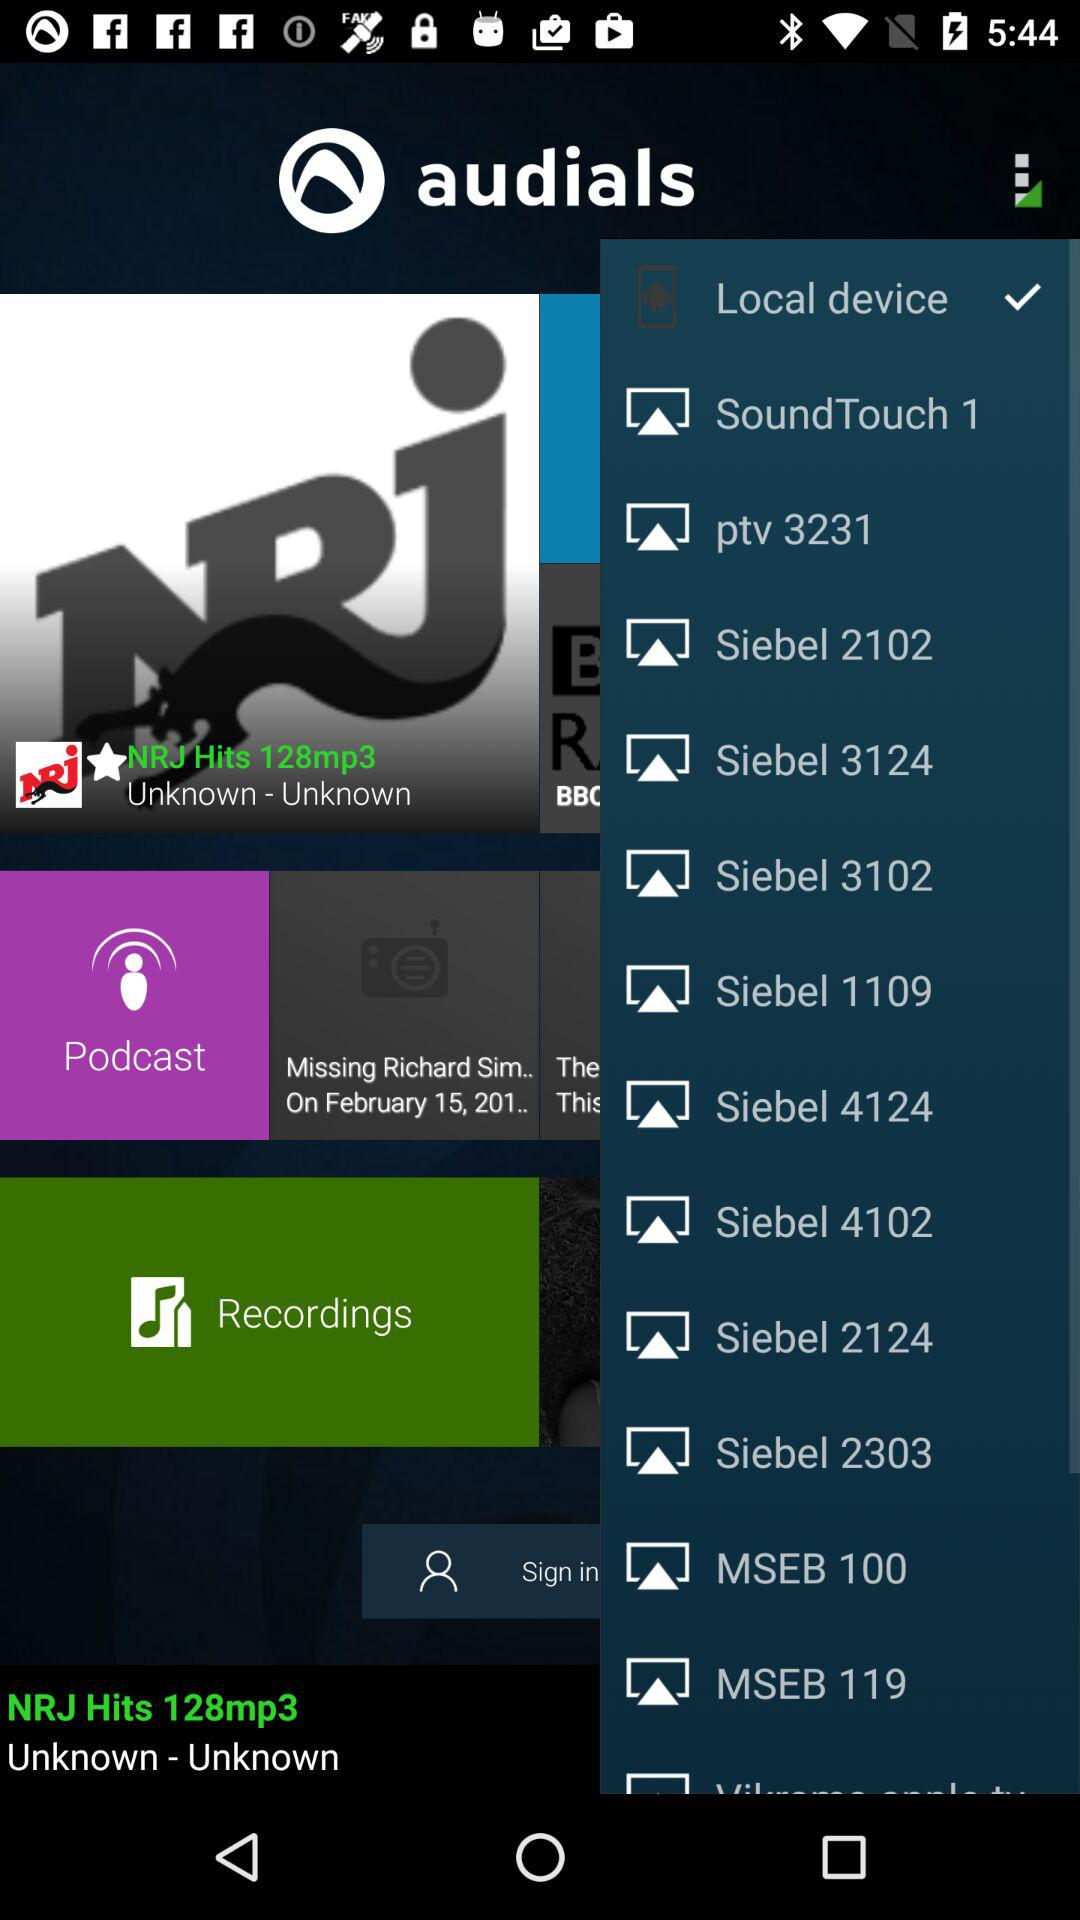What is the name of the application? The name of the application is "audials". 